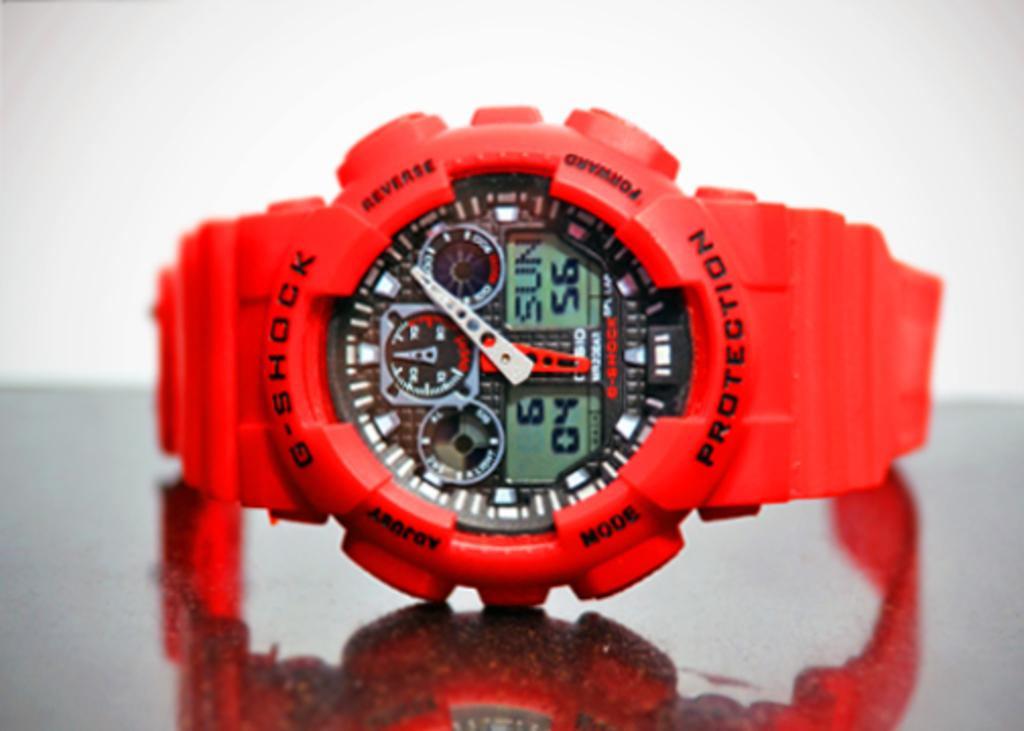<image>
Describe the image concisely. A G-Shock watch has both digital and analog readouts. 